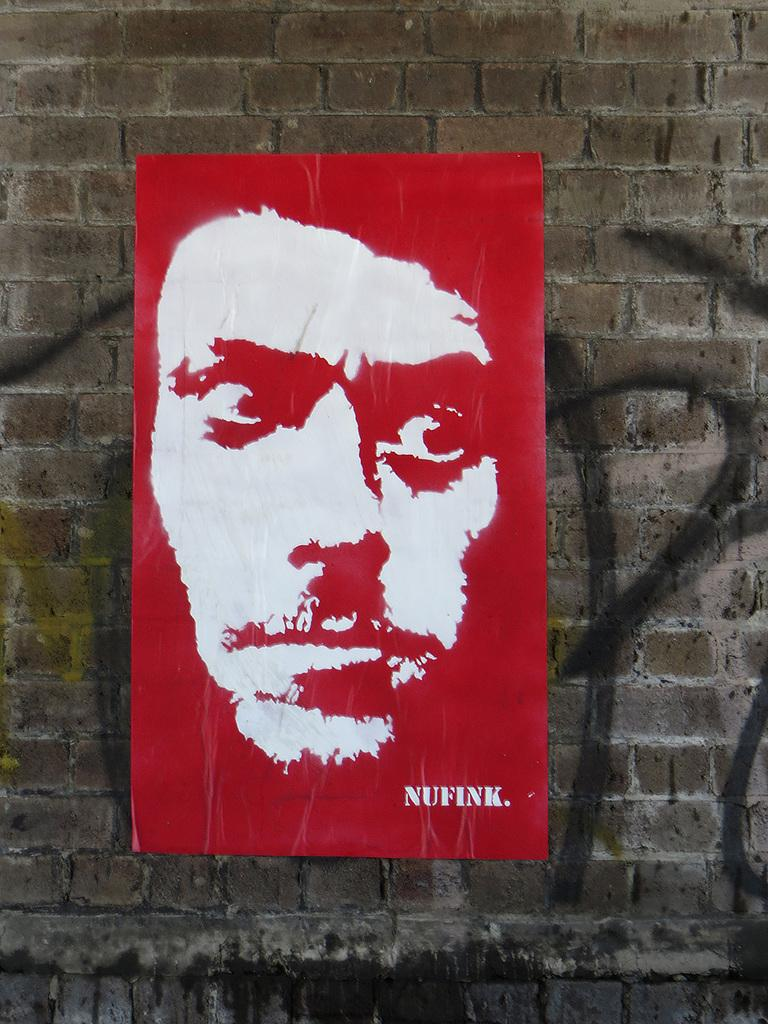<image>
Write a terse but informative summary of the picture. Red poster on the brick wall with the name NUFINK on the bottom. 